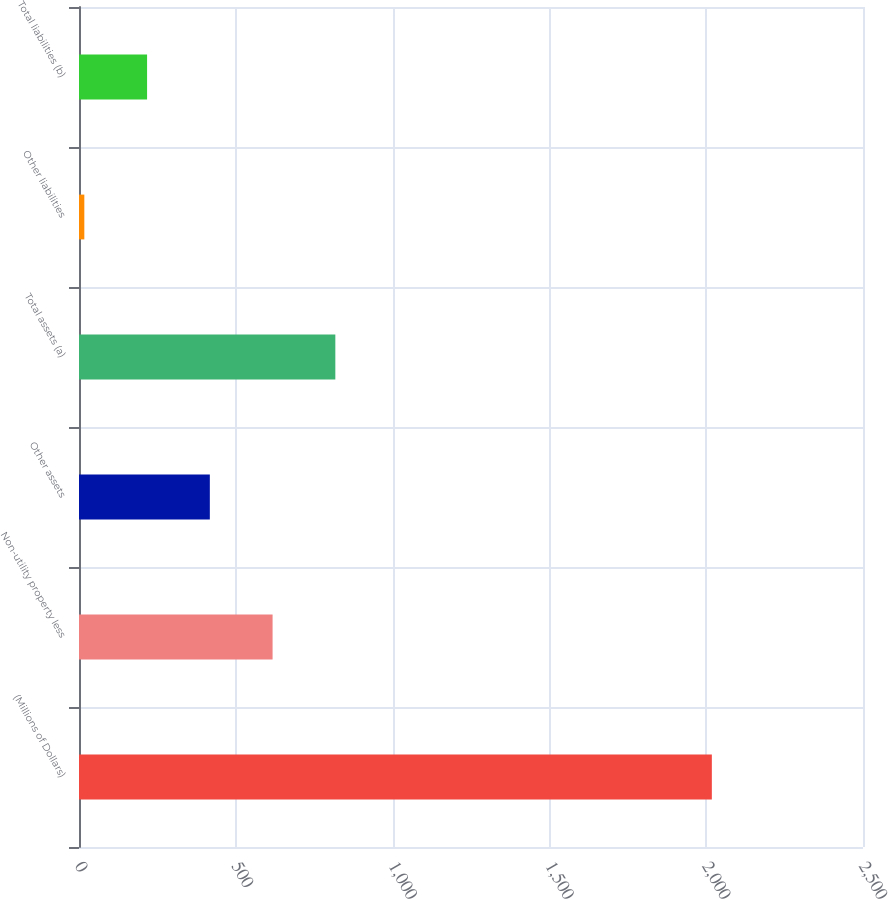<chart> <loc_0><loc_0><loc_500><loc_500><bar_chart><fcel>(Millions of Dollars)<fcel>Non-utility property less<fcel>Other assets<fcel>Total assets (a)<fcel>Other liabilities<fcel>Total liabilities (b)<nl><fcel>2018<fcel>617.3<fcel>417.2<fcel>817.4<fcel>17<fcel>217.1<nl></chart> 